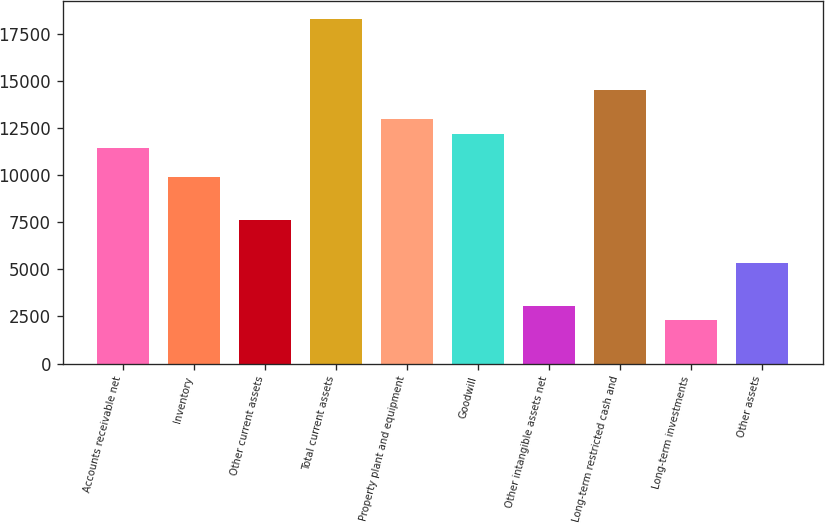Convert chart to OTSL. <chart><loc_0><loc_0><loc_500><loc_500><bar_chart><fcel>Accounts receivable net<fcel>Inventory<fcel>Other current assets<fcel>Total current assets<fcel>Property plant and equipment<fcel>Goodwill<fcel>Other intangible assets net<fcel>Long-term restricted cash and<fcel>Long-term investments<fcel>Other assets<nl><fcel>11440<fcel>9914.8<fcel>7627<fcel>18303.4<fcel>12965.2<fcel>12202.6<fcel>3051.4<fcel>14490.4<fcel>2288.8<fcel>5339.2<nl></chart> 